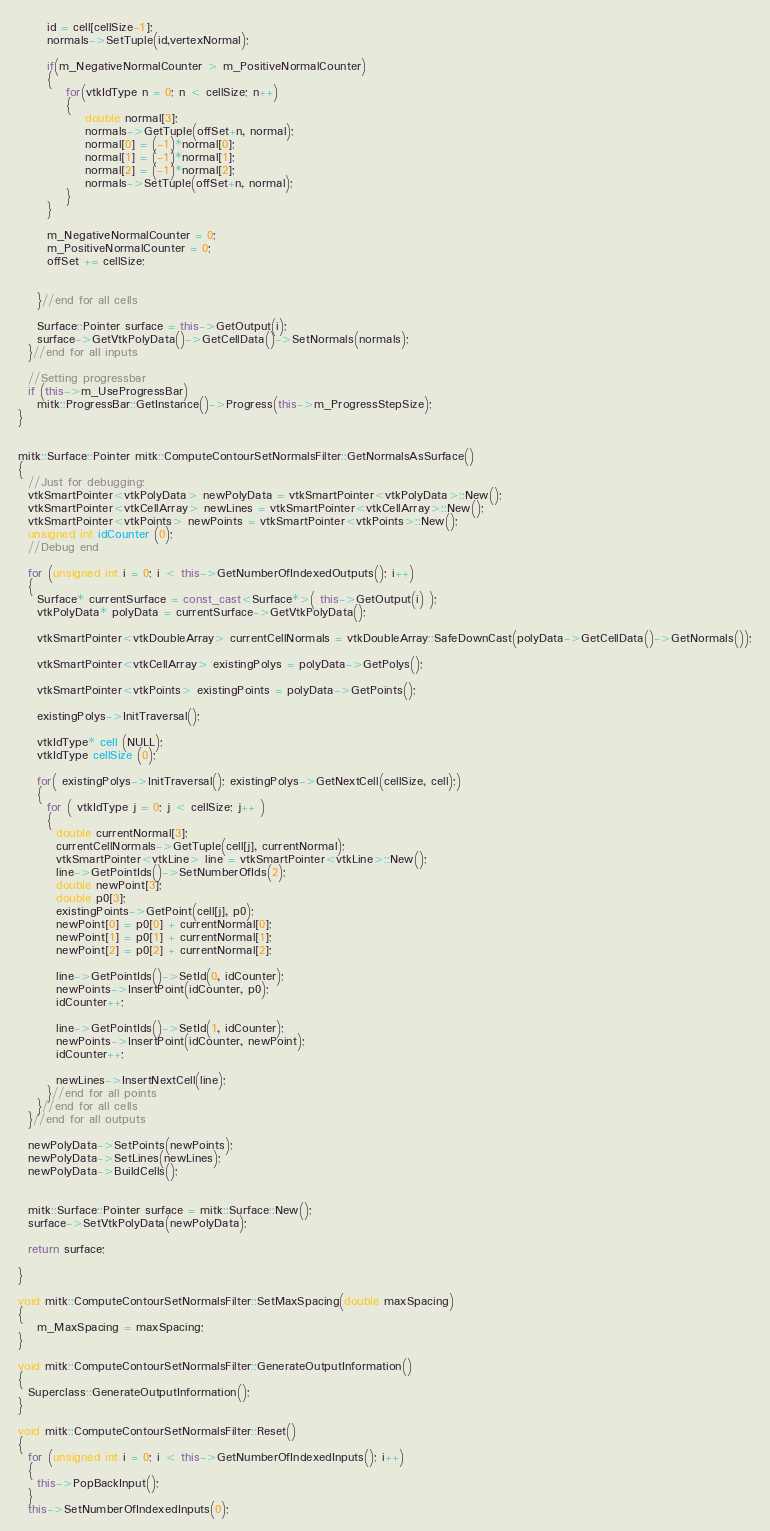<code> <loc_0><loc_0><loc_500><loc_500><_C++_>      id = cell[cellSize-1];
      normals->SetTuple(id,vertexNormal);

      if(m_NegativeNormalCounter > m_PositiveNormalCounter)
      {
          for(vtkIdType n = 0; n < cellSize; n++)
          {
              double normal[3];
              normals->GetTuple(offSet+n, normal);
              normal[0] = (-1)*normal[0];
              normal[1] = (-1)*normal[1];
              normal[2] = (-1)*normal[2];
              normals->SetTuple(offSet+n, normal);
          }
      }

      m_NegativeNormalCounter = 0;
      m_PositiveNormalCounter = 0;
      offSet += cellSize;


    }//end for all cells

    Surface::Pointer surface = this->GetOutput(i);
    surface->GetVtkPolyData()->GetCellData()->SetNormals(normals);
  }//end for all inputs

  //Setting progressbar
  if (this->m_UseProgressBar)
    mitk::ProgressBar::GetInstance()->Progress(this->m_ProgressStepSize);
}


mitk::Surface::Pointer mitk::ComputeContourSetNormalsFilter::GetNormalsAsSurface()
{
  //Just for debugging:
  vtkSmartPointer<vtkPolyData> newPolyData = vtkSmartPointer<vtkPolyData>::New();
  vtkSmartPointer<vtkCellArray> newLines = vtkSmartPointer<vtkCellArray>::New();
  vtkSmartPointer<vtkPoints> newPoints = vtkSmartPointer<vtkPoints>::New();
  unsigned int idCounter (0);
  //Debug end

  for (unsigned int i = 0; i < this->GetNumberOfIndexedOutputs(); i++)
  {
    Surface* currentSurface = const_cast<Surface*>( this->GetOutput(i) );
    vtkPolyData* polyData = currentSurface->GetVtkPolyData();

    vtkSmartPointer<vtkDoubleArray> currentCellNormals = vtkDoubleArray::SafeDownCast(polyData->GetCellData()->GetNormals());

    vtkSmartPointer<vtkCellArray> existingPolys = polyData->GetPolys();

    vtkSmartPointer<vtkPoints> existingPoints = polyData->GetPoints();

    existingPolys->InitTraversal();

    vtkIdType* cell (NULL);
    vtkIdType cellSize (0);

    for( existingPolys->InitTraversal(); existingPolys->GetNextCell(cellSize, cell);)
    {
      for ( vtkIdType j = 0; j < cellSize; j++ )
      {
        double currentNormal[3];
        currentCellNormals->GetTuple(cell[j], currentNormal);
        vtkSmartPointer<vtkLine> line = vtkSmartPointer<vtkLine>::New();
        line->GetPointIds()->SetNumberOfIds(2);
        double newPoint[3];
        double p0[3];
        existingPoints->GetPoint(cell[j], p0);
        newPoint[0] = p0[0] + currentNormal[0];
        newPoint[1] = p0[1] + currentNormal[1];
        newPoint[2] = p0[2] + currentNormal[2];

        line->GetPointIds()->SetId(0, idCounter);
        newPoints->InsertPoint(idCounter, p0);
        idCounter++;

        line->GetPointIds()->SetId(1, idCounter);
        newPoints->InsertPoint(idCounter, newPoint);
        idCounter++;

        newLines->InsertNextCell(line);
      }//end for all points
    }//end for all cells
  }//end for all outputs

  newPolyData->SetPoints(newPoints);
  newPolyData->SetLines(newLines);
  newPolyData->BuildCells();


  mitk::Surface::Pointer surface = mitk::Surface::New();
  surface->SetVtkPolyData(newPolyData);

  return surface;

}

void mitk::ComputeContourSetNormalsFilter::SetMaxSpacing(double maxSpacing)
{
    m_MaxSpacing = maxSpacing;
}

void mitk::ComputeContourSetNormalsFilter::GenerateOutputInformation()
{
  Superclass::GenerateOutputInformation();
}

void mitk::ComputeContourSetNormalsFilter::Reset()
{
  for (unsigned int i = 0; i < this->GetNumberOfIndexedInputs(); i++)
  {
    this->PopBackInput();
  }
  this->SetNumberOfIndexedInputs(0);</code> 